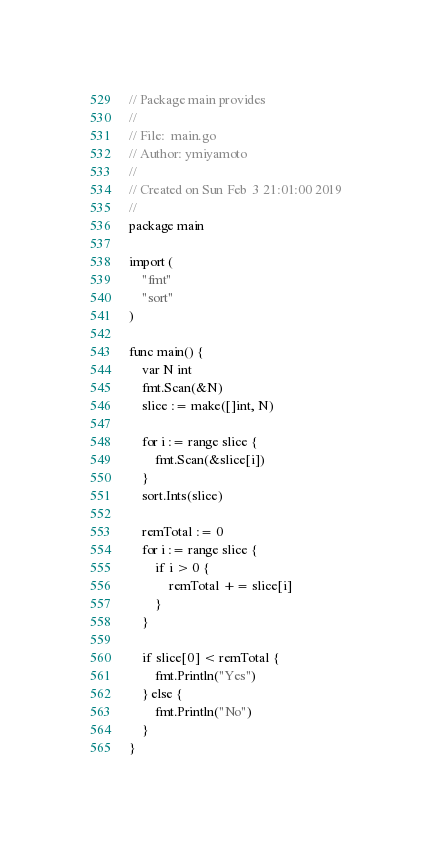Convert code to text. <code><loc_0><loc_0><loc_500><loc_500><_Go_>// Package main provides
//
// File:  main.go
// Author: ymiyamoto
//
// Created on Sun Feb  3 21:01:00 2019
//
package main

import (
	"fmt"
	"sort"
)

func main() {
	var N int
	fmt.Scan(&N)
	slice := make([]int, N)

	for i := range slice {
		fmt.Scan(&slice[i])
	}
	sort.Ints(slice)

	remTotal := 0
	for i := range slice {
		if i > 0 {
			remTotal += slice[i]
		}
	}

	if slice[0] < remTotal {
		fmt.Println("Yes")
	} else {
		fmt.Println("No")
	}
}
</code> 